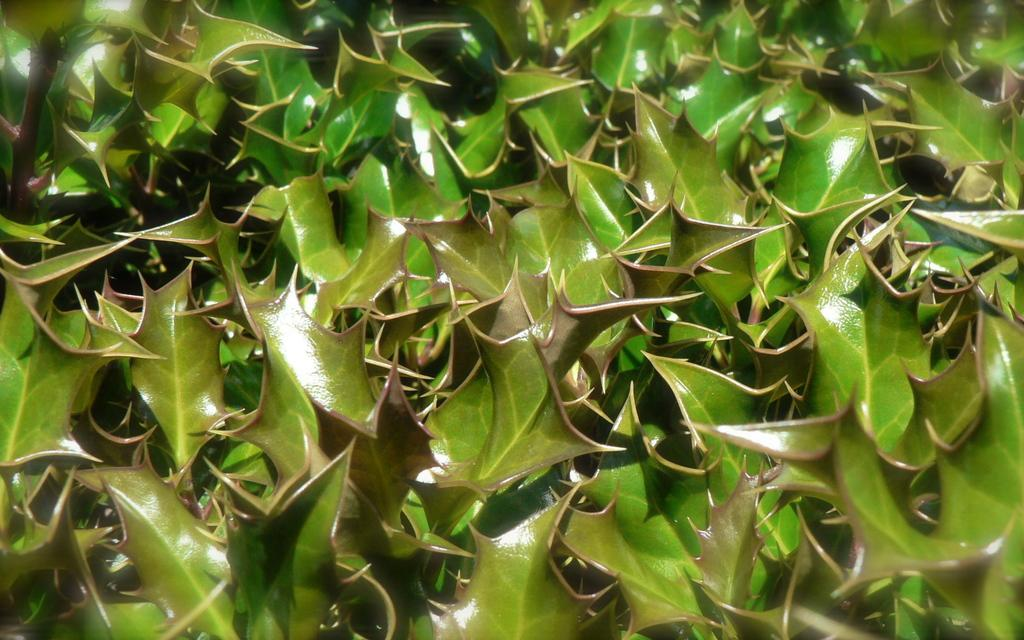What color are the leaves in the image? The leaves in the image are green. Can you see a beetle crawling on the leaves in the image? There is no beetle present in the image; it only features green color leaves. What type of bag is hanging from the leaves in the image? There is no bag present in the image; it only features green color leaves. 